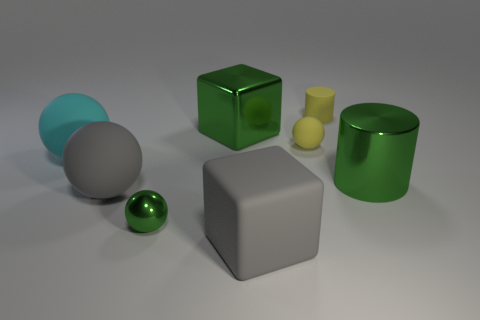Please tell me about the sizes of these objects. There are objects of varying sizes: the gray and green cylinders and the white cube are the largest, followed by the green cube and the yellow cylinder. The smallest objects are the green sphere and the cyan cylinder. Do the objects seem to be arranged in a specific pattern? The objects do not appear to be arranged in a specific pattern; they are placed randomly across the surface. 